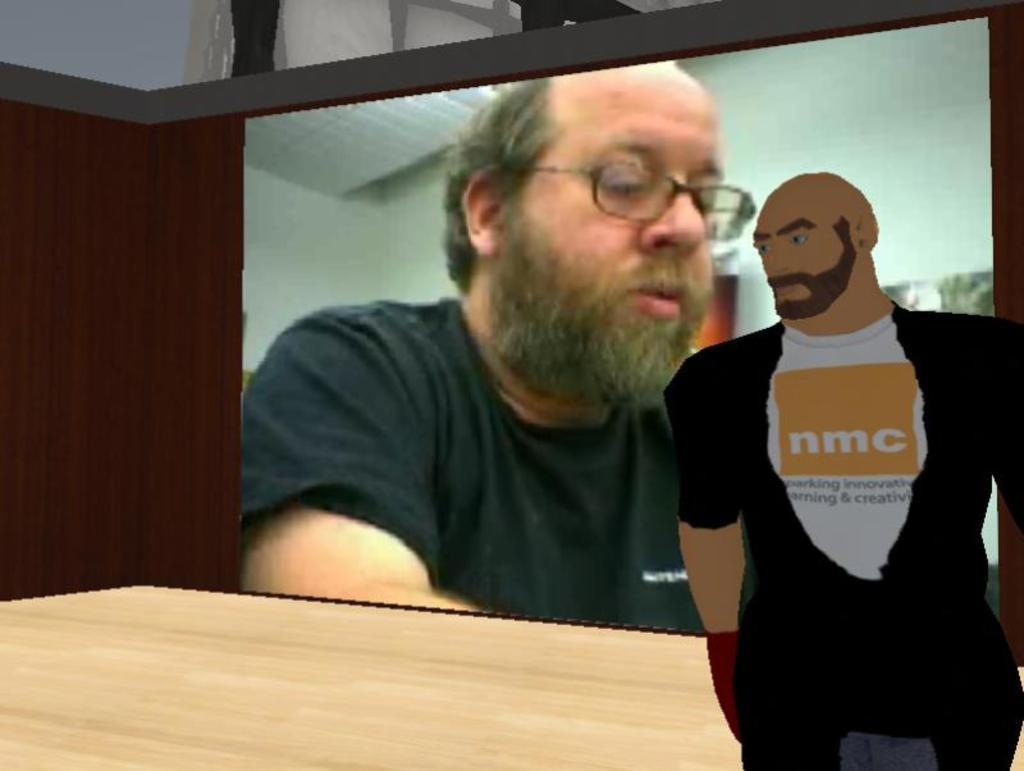What can be said about the nature of the image? The image is edited. What type of structure is present in the image? There is a wall in the image. What surface is visible in the image? There is a floor in the image. What is depicted in the image besides the wall and floor? There is a picture of a person in the image. What other object is present in the image? There is a screen in the image. Who can be seen on the screen? A man is visible on the screen. What is the weather like in the image? The provided facts do not mention any weather conditions, so it cannot be determined from the image. What beliefs are held by the person in the picture? The provided facts do not mention any beliefs held by the person in the picture, so it cannot be determined from the image. 